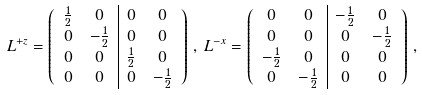Convert formula to latex. <formula><loc_0><loc_0><loc_500><loc_500>& L ^ { + z } = \left ( \begin{array} { c c | c c } \frac { 1 } { 2 } & 0 & 0 & 0 \\ 0 & - \frac { 1 } { 2 } & 0 & 0 \\ 0 & 0 & \frac { 1 } { 2 } & 0 \\ 0 & 0 & 0 & - \frac { 1 } { 2 } \end{array} \right ) \, , \, L ^ { - x } = \left ( \begin{array} { c c | c c } 0 & 0 & - \frac { 1 } { 2 } & 0 \\ 0 & 0 & 0 & - \frac { 1 } { 2 } \\ - \frac { 1 } { 2 } & 0 & 0 & 0 \\ 0 & - \frac { 1 } { 2 } & 0 & 0 \end{array} \right ) \, ,</formula> 